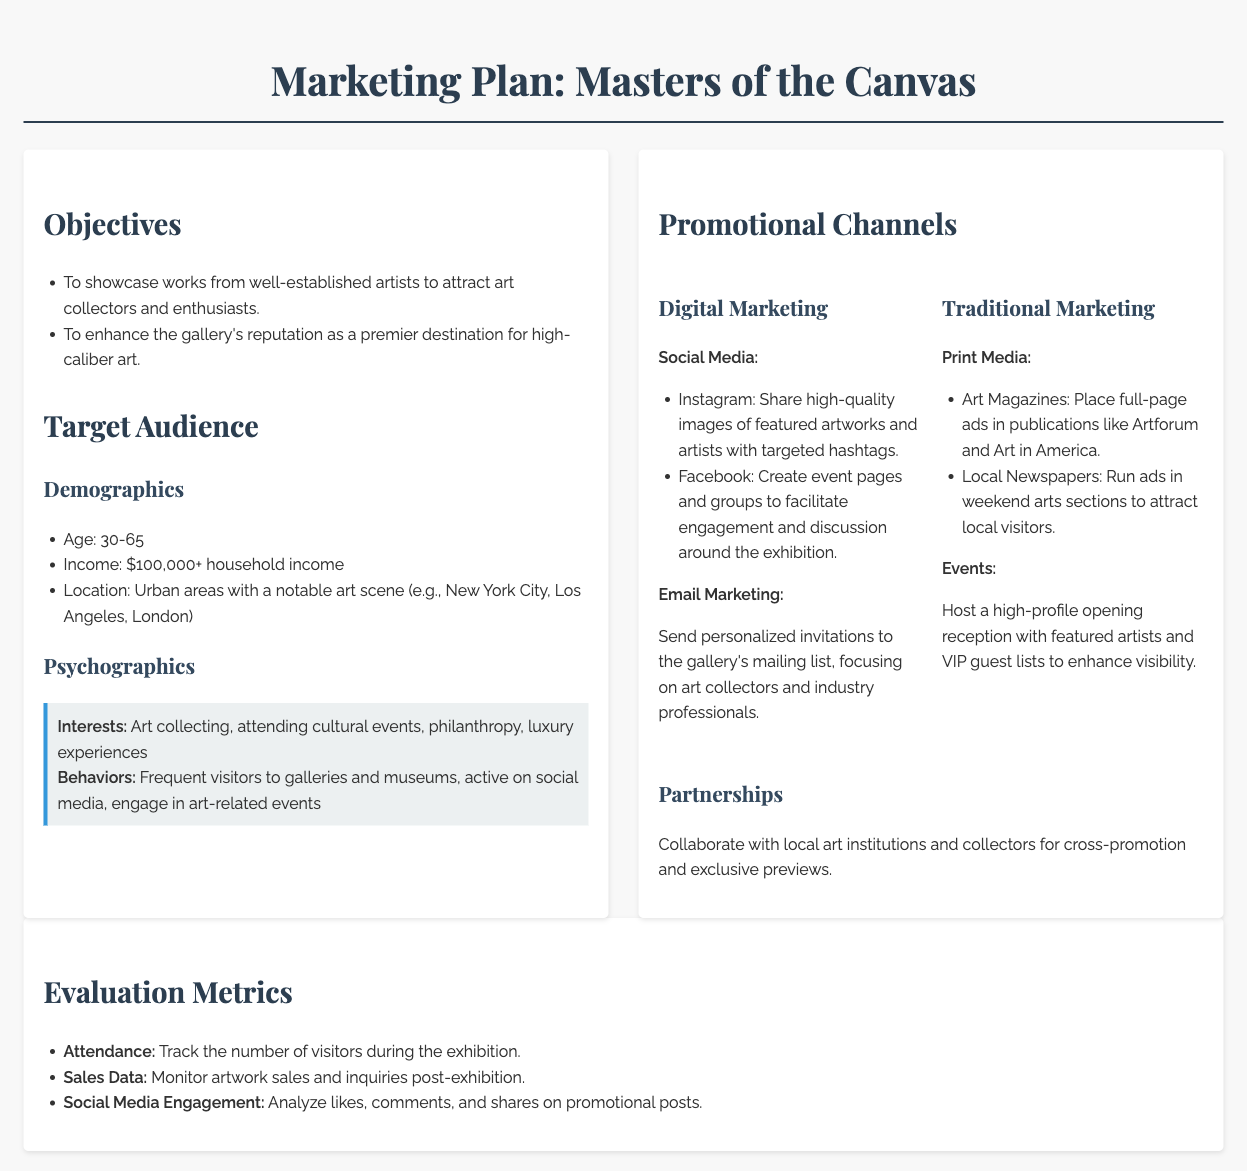What are the exhibition objectives? The objectives are outlined clearly, with specific goals to be achieved through the exhibition.
Answer: To showcase works from well-established artists to attract art collectors and enthusiasts; To enhance the gallery's reputation as a premier destination for high-caliber art What is the age range of the target audience? The age range is a specific demographic detail mentioned in the target audience section.
Answer: 30-65 What promotional channel involves social media? The promotional channels section includes various avenues for marketing, including digital methods.
Answer: Digital Marketing Name one type of print media used for promotion. The document lists specific channels within traditional marketing, including types of media.
Answer: Art Magazines What is the household income threshold for the target audience? This detail provides demographic information crucial for audience analysis.
Answer: $100,000+ What is a key interest of the target audience? Interests of the psychographics segment provide insight into the audience's preferences.
Answer: Art collecting How will social media engagement be evaluated? Evaluation metrics offer ways to measure success after the exhibition, specifically for online promotion.
Answer: Analyze likes, comments, and shares on promotional posts Which cities are mentioned for the target audience location? The location is a crucial demographic factor mentioned in the target audience analysis.
Answer: New York City, Los Angeles, London What is one way to enhance exhibition visibility? Suggested strategies for promotion often relate to event management and marketing efforts.
Answer: Host a high-profile opening reception with featured artists and VIP guest lists 